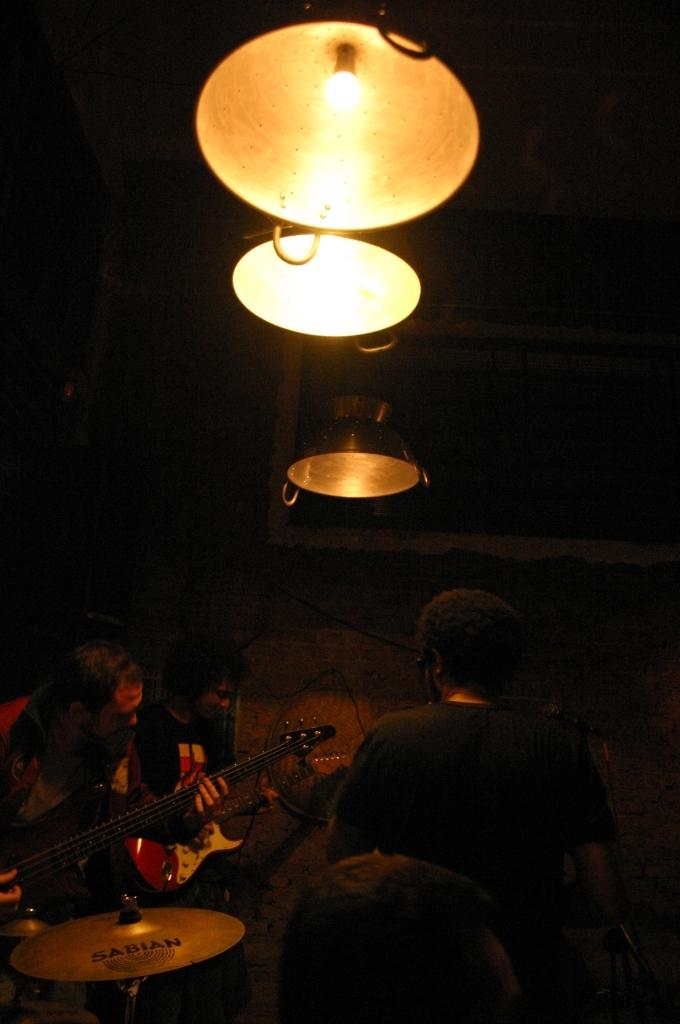What type of setting is depicted in the image? The image shows an inside view of a room. Are there any people in the room? Yes, there are persons in the room. What are the persons in the room doing? The persons are playing musical instruments. How many lights are visible in the room? There are three lights at the top of the room. What type of potato is being used as a drumstick in the image? There is no potato or drumstick present in the image; the persons are playing musical instruments with their hands or other appropriate tools. 